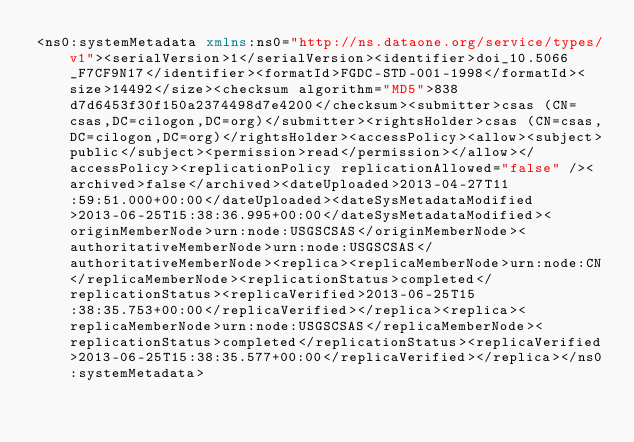<code> <loc_0><loc_0><loc_500><loc_500><_XML_><ns0:systemMetadata xmlns:ns0="http://ns.dataone.org/service/types/v1"><serialVersion>1</serialVersion><identifier>doi_10.5066_F7CF9N17</identifier><formatId>FGDC-STD-001-1998</formatId><size>14492</size><checksum algorithm="MD5">838d7d6453f30f150a2374498d7e4200</checksum><submitter>csas (CN=csas,DC=cilogon,DC=org)</submitter><rightsHolder>csas (CN=csas,DC=cilogon,DC=org)</rightsHolder><accessPolicy><allow><subject>public</subject><permission>read</permission></allow></accessPolicy><replicationPolicy replicationAllowed="false" /><archived>false</archived><dateUploaded>2013-04-27T11:59:51.000+00:00</dateUploaded><dateSysMetadataModified>2013-06-25T15:38:36.995+00:00</dateSysMetadataModified><originMemberNode>urn:node:USGSCSAS</originMemberNode><authoritativeMemberNode>urn:node:USGSCSAS</authoritativeMemberNode><replica><replicaMemberNode>urn:node:CN</replicaMemberNode><replicationStatus>completed</replicationStatus><replicaVerified>2013-06-25T15:38:35.753+00:00</replicaVerified></replica><replica><replicaMemberNode>urn:node:USGSCSAS</replicaMemberNode><replicationStatus>completed</replicationStatus><replicaVerified>2013-06-25T15:38:35.577+00:00</replicaVerified></replica></ns0:systemMetadata></code> 